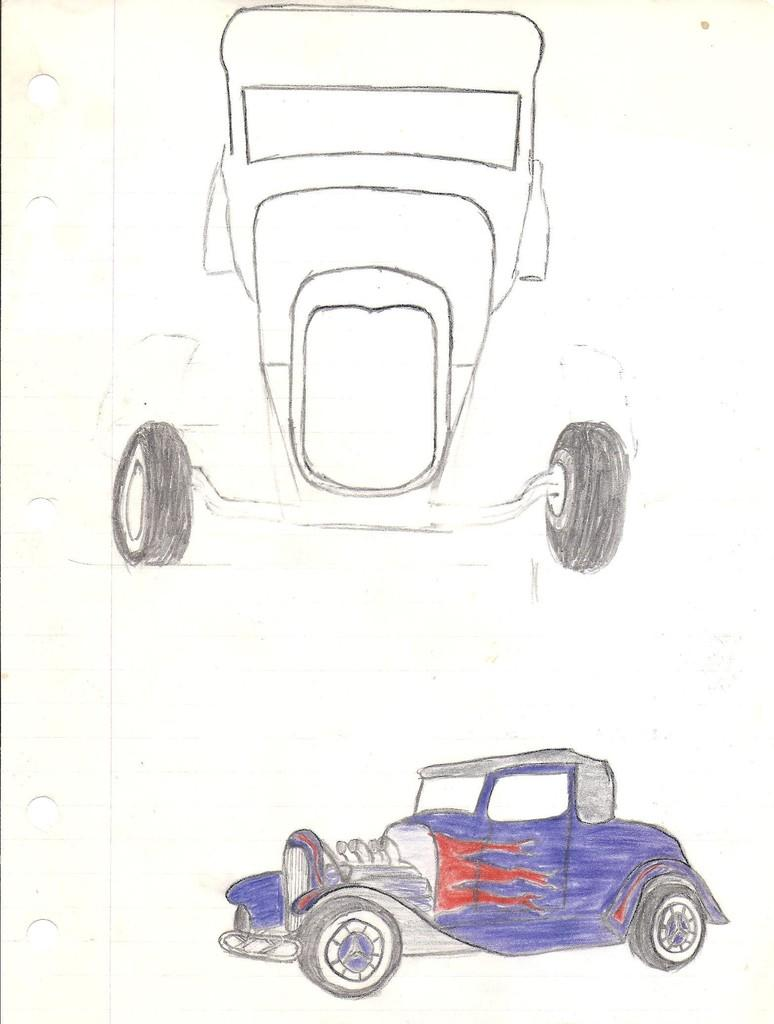What is the main subject in the center of the image? There is a paper in the center of the image. What is depicted on the paper? The paper contains a drawing. What type of objects are featured in the drawing? The drawing depicts vehicles. Are there any colors used in the drawing? Yes, there are colors present on one of the vehicles in the drawing. What type of trousers is the person wearing in the image? There is no person present in the image, only a paper with a drawing of vehicles. What holiday is being celebrated in the image? There is no indication of a holiday being celebrated in the image. 